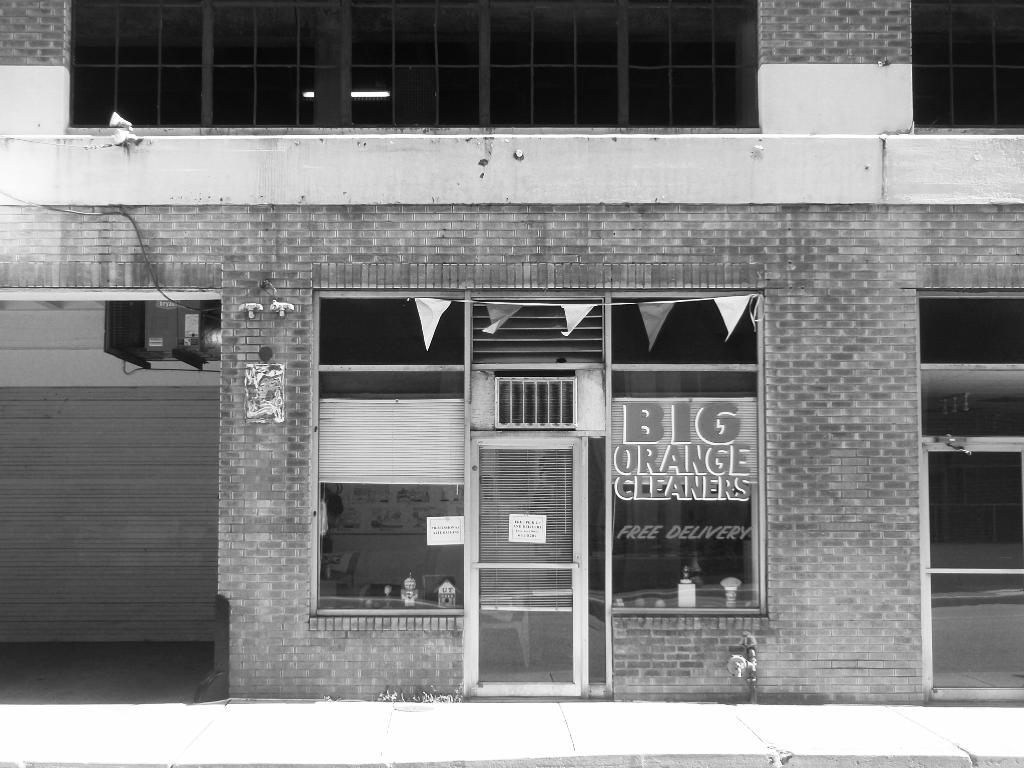What type of structure is present in the image? There is a building in the image. What feature can be seen on the building? The building has windows. What else is present in the image besides the building? There is a poster with text in the image. How does the crowd interact with the building in the image? There is no crowd present in the image; it only features a building and a poster with text. 